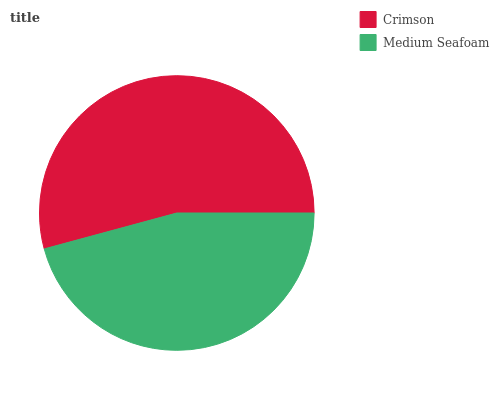Is Medium Seafoam the minimum?
Answer yes or no. Yes. Is Crimson the maximum?
Answer yes or no. Yes. Is Medium Seafoam the maximum?
Answer yes or no. No. Is Crimson greater than Medium Seafoam?
Answer yes or no. Yes. Is Medium Seafoam less than Crimson?
Answer yes or no. Yes. Is Medium Seafoam greater than Crimson?
Answer yes or no. No. Is Crimson less than Medium Seafoam?
Answer yes or no. No. Is Crimson the high median?
Answer yes or no. Yes. Is Medium Seafoam the low median?
Answer yes or no. Yes. Is Medium Seafoam the high median?
Answer yes or no. No. Is Crimson the low median?
Answer yes or no. No. 